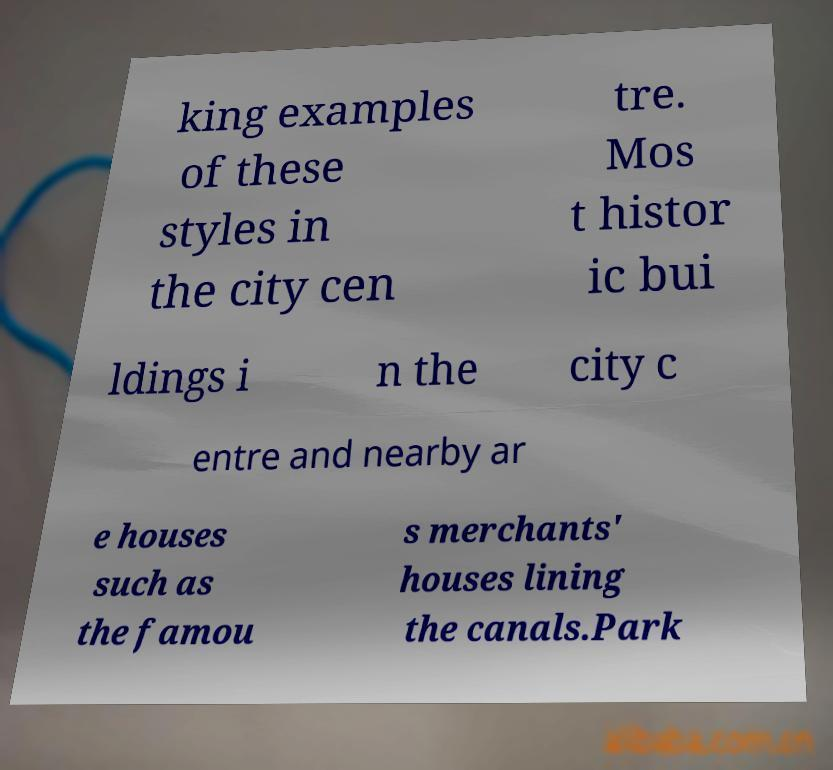Could you assist in decoding the text presented in this image and type it out clearly? king examples of these styles in the city cen tre. Mos t histor ic bui ldings i n the city c entre and nearby ar e houses such as the famou s merchants' houses lining the canals.Park 